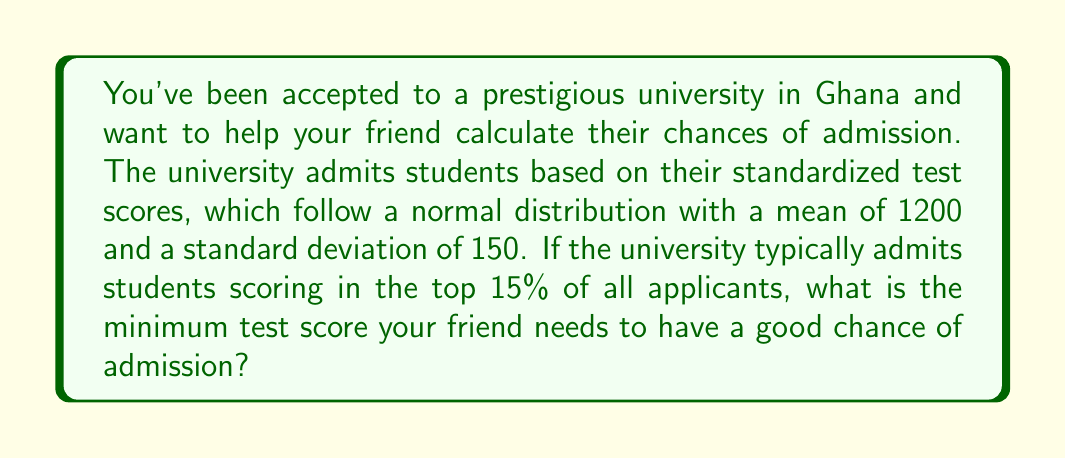Give your solution to this math problem. Let's approach this step-by-step:

1) We're dealing with a normal distribution where:
   $\mu = 1200$ (mean)
   $\sigma = 150$ (standard deviation)

2) We need to find the score that corresponds to the 85th percentile (top 15%).

3) For a normal distribution, we can use the z-score formula:
   $z = \frac{x - \mu}{\sigma}$

4) The z-score for the 85th percentile is approximately 1.04 (from standard normal distribution tables).

5) Now we can plug this into our formula:
   $1.04 = \frac{x - 1200}{150}$

6) Solve for x:
   $150 * 1.04 = x - 1200$
   $156 = x - 1200$
   $x = 1356$

Therefore, your friend needs a score of at least 1356 to be in the top 15% of applicants.
Answer: 1356 